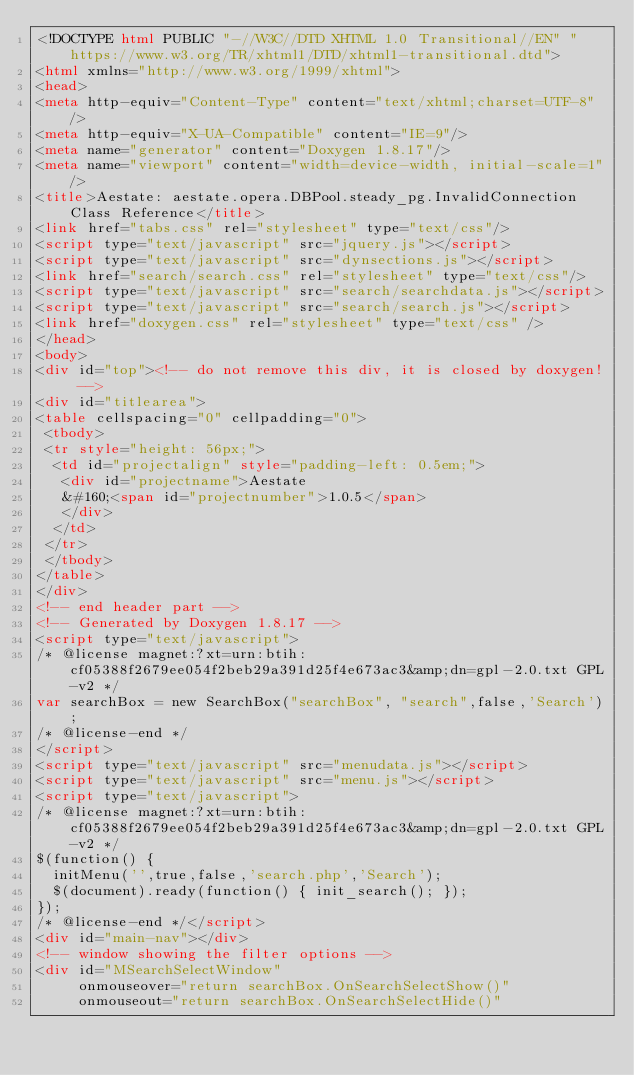Convert code to text. <code><loc_0><loc_0><loc_500><loc_500><_HTML_><!DOCTYPE html PUBLIC "-//W3C//DTD XHTML 1.0 Transitional//EN" "https://www.w3.org/TR/xhtml1/DTD/xhtml1-transitional.dtd">
<html xmlns="http://www.w3.org/1999/xhtml">
<head>
<meta http-equiv="Content-Type" content="text/xhtml;charset=UTF-8"/>
<meta http-equiv="X-UA-Compatible" content="IE=9"/>
<meta name="generator" content="Doxygen 1.8.17"/>
<meta name="viewport" content="width=device-width, initial-scale=1"/>
<title>Aestate: aestate.opera.DBPool.steady_pg.InvalidConnection Class Reference</title>
<link href="tabs.css" rel="stylesheet" type="text/css"/>
<script type="text/javascript" src="jquery.js"></script>
<script type="text/javascript" src="dynsections.js"></script>
<link href="search/search.css" rel="stylesheet" type="text/css"/>
<script type="text/javascript" src="search/searchdata.js"></script>
<script type="text/javascript" src="search/search.js"></script>
<link href="doxygen.css" rel="stylesheet" type="text/css" />
</head>
<body>
<div id="top"><!-- do not remove this div, it is closed by doxygen! -->
<div id="titlearea">
<table cellspacing="0" cellpadding="0">
 <tbody>
 <tr style="height: 56px;">
  <td id="projectalign" style="padding-left: 0.5em;">
   <div id="projectname">Aestate
   &#160;<span id="projectnumber">1.0.5</span>
   </div>
  </td>
 </tr>
 </tbody>
</table>
</div>
<!-- end header part -->
<!-- Generated by Doxygen 1.8.17 -->
<script type="text/javascript">
/* @license magnet:?xt=urn:btih:cf05388f2679ee054f2beb29a391d25f4e673ac3&amp;dn=gpl-2.0.txt GPL-v2 */
var searchBox = new SearchBox("searchBox", "search",false,'Search');
/* @license-end */
</script>
<script type="text/javascript" src="menudata.js"></script>
<script type="text/javascript" src="menu.js"></script>
<script type="text/javascript">
/* @license magnet:?xt=urn:btih:cf05388f2679ee054f2beb29a391d25f4e673ac3&amp;dn=gpl-2.0.txt GPL-v2 */
$(function() {
  initMenu('',true,false,'search.php','Search');
  $(document).ready(function() { init_search(); });
});
/* @license-end */</script>
<div id="main-nav"></div>
<!-- window showing the filter options -->
<div id="MSearchSelectWindow"
     onmouseover="return searchBox.OnSearchSelectShow()"
     onmouseout="return searchBox.OnSearchSelectHide()"</code> 